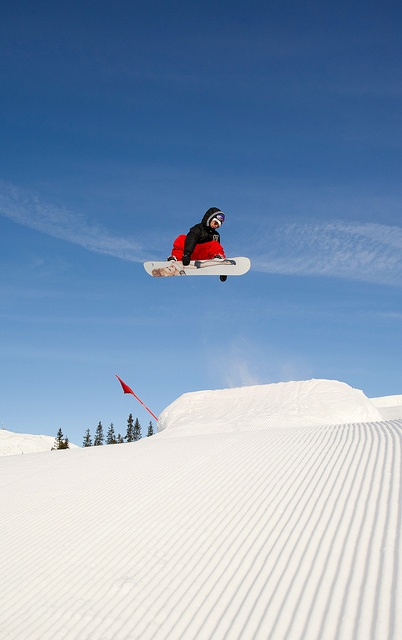Describe the objects in this image and their specific colors. I can see snowboard in darkblue, lightgray, tan, and darkgray tones and people in darkblue, black, red, and maroon tones in this image. 